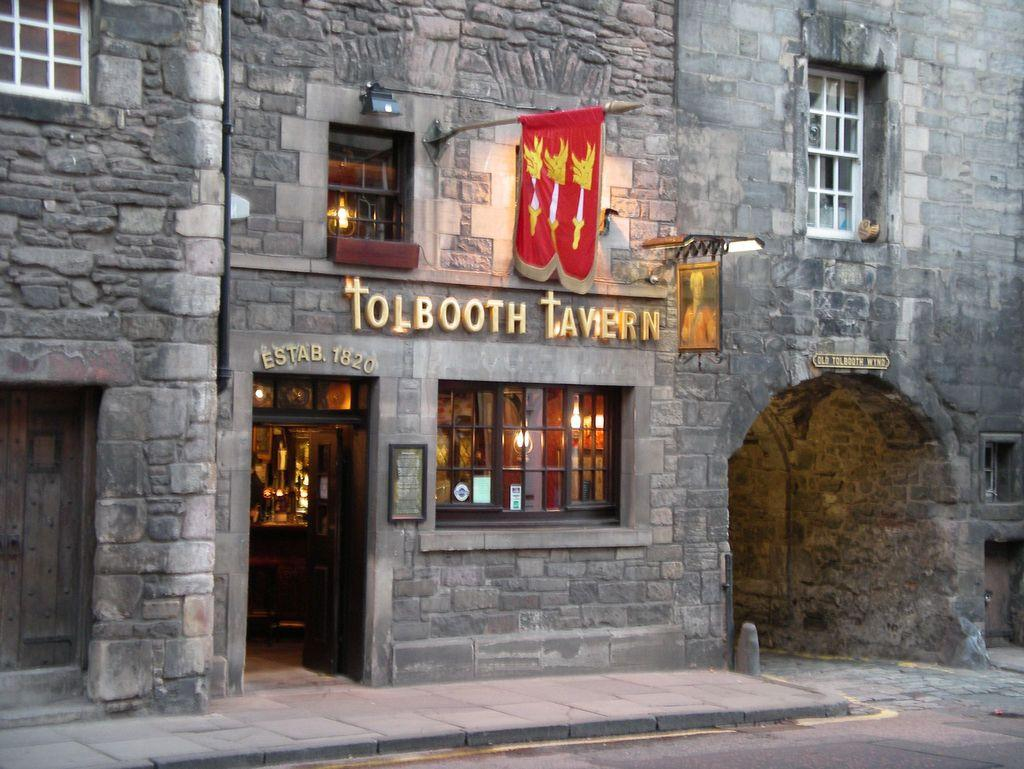What is the main feature of the image? There is a road in the image. What else can be seen in the image besides the road? There is a building, windows, light, a flag, and a frame attached to the wall in the image. Can you describe the building in the image? There is a building in the image, but no specific details about its appearance are provided. What is the purpose of the flag in the image? The purpose of the flag in the image is not mentioned, but it could be a symbol of a country, organization, or event. How does the giraffe interact with the waste in the image? There is no giraffe or waste present in the image. What type of alarm is used to signal the start of the event in the image? There is no event or alarm present in the image. 